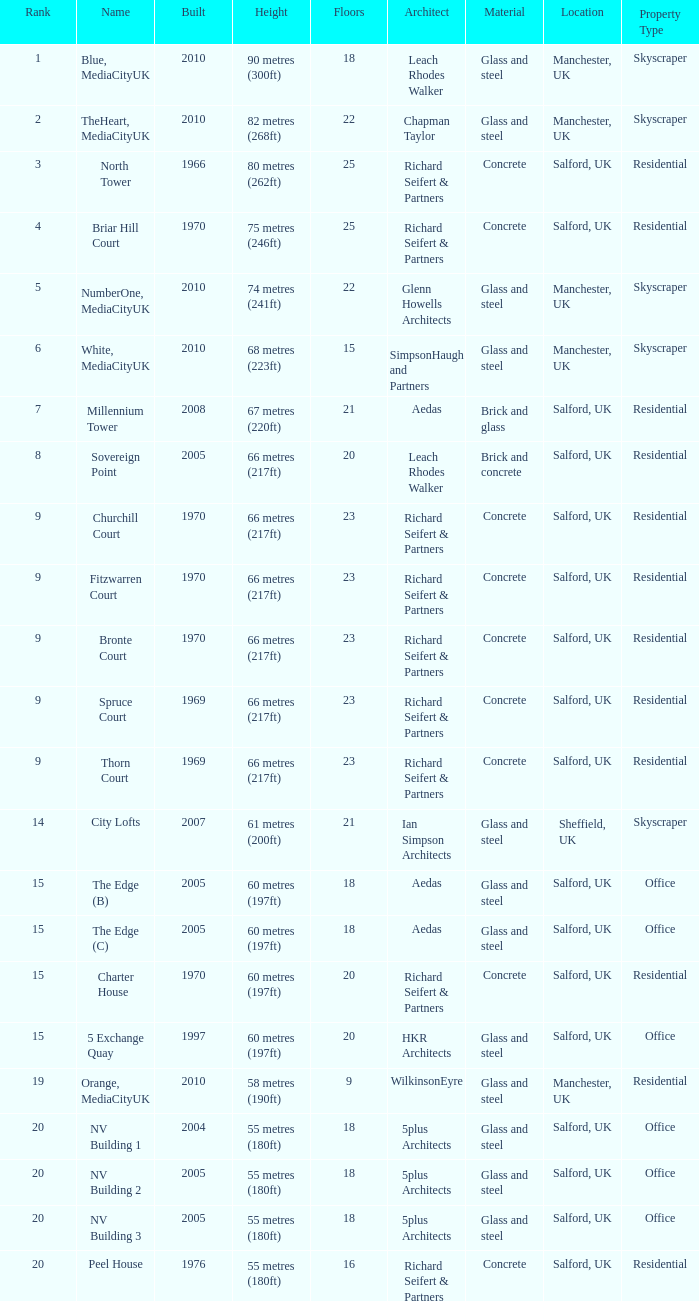What is Height, when Rank is less than 20, when Floors is greater than 9, when Built is 2005, and when Name is The Edge (C)? 60 metres (197ft). 